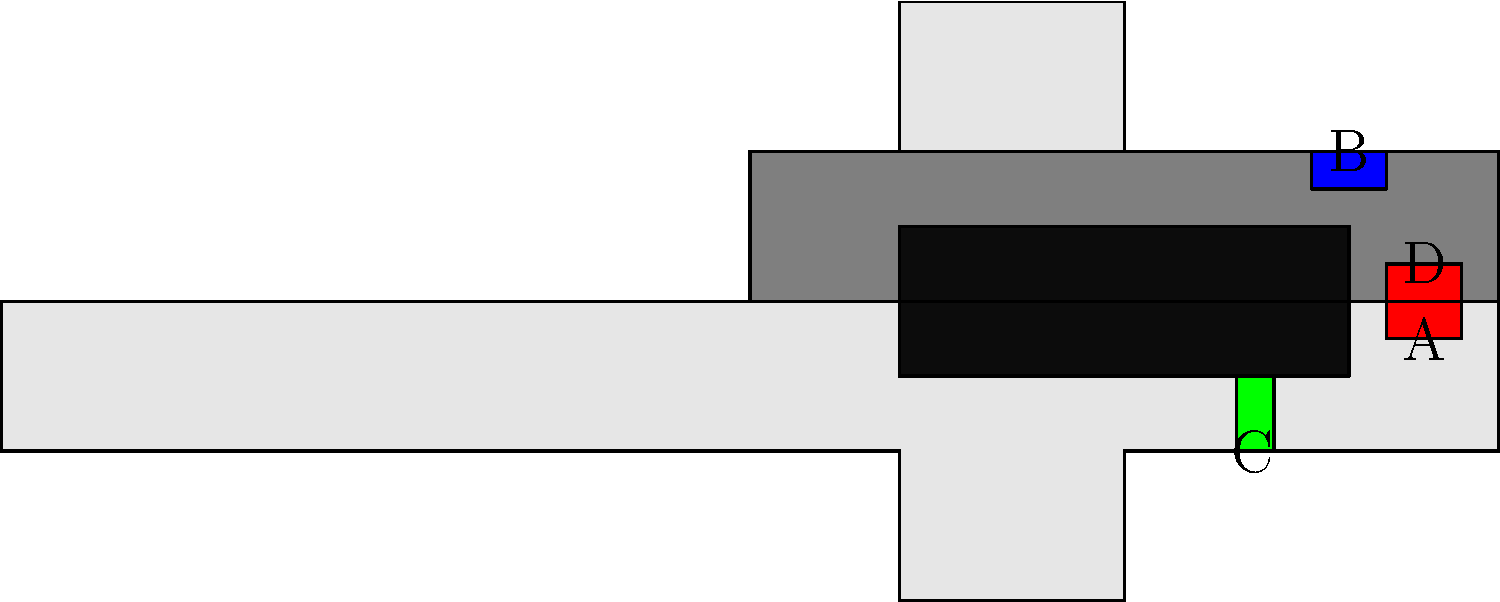In the cutaway diagram of a semi-automatic pistol, identify the component labeled 'B' and explain its primary function in the firing and ejection process. To answer this question, let's break down the components and their functions in a semi-automatic pistol:

1. The diagram shows a cutaway view of a semi-automatic pistol, revealing its internal mechanics.

2. There are four labeled components: A, B, C, and D.

3. Component B is located at the rear top of the slide, near the ejection port.

4. This position and shape are characteristic of the extractor in a semi-automatic pistol.

5. The extractor's primary functions are:
   a) To grip the rim of the cartridge case as it's chambered.
   b) To pull the spent casing out of the chamber during the slide's rearward movement after firing.
   c) To hold the casing in position until it strikes the ejector.

6. The extractor works in conjunction with the ejector (likely component C) to ensure reliable ejection of spent casings.

7. This process is crucial for the semi-automatic operation, as it clears the chamber for the next round to be loaded.

Therefore, component B is the extractor, and its primary function is to remove the spent casing from the chamber during the pistol's firing cycle.
Answer: Extractor; removes spent casing from chamber 